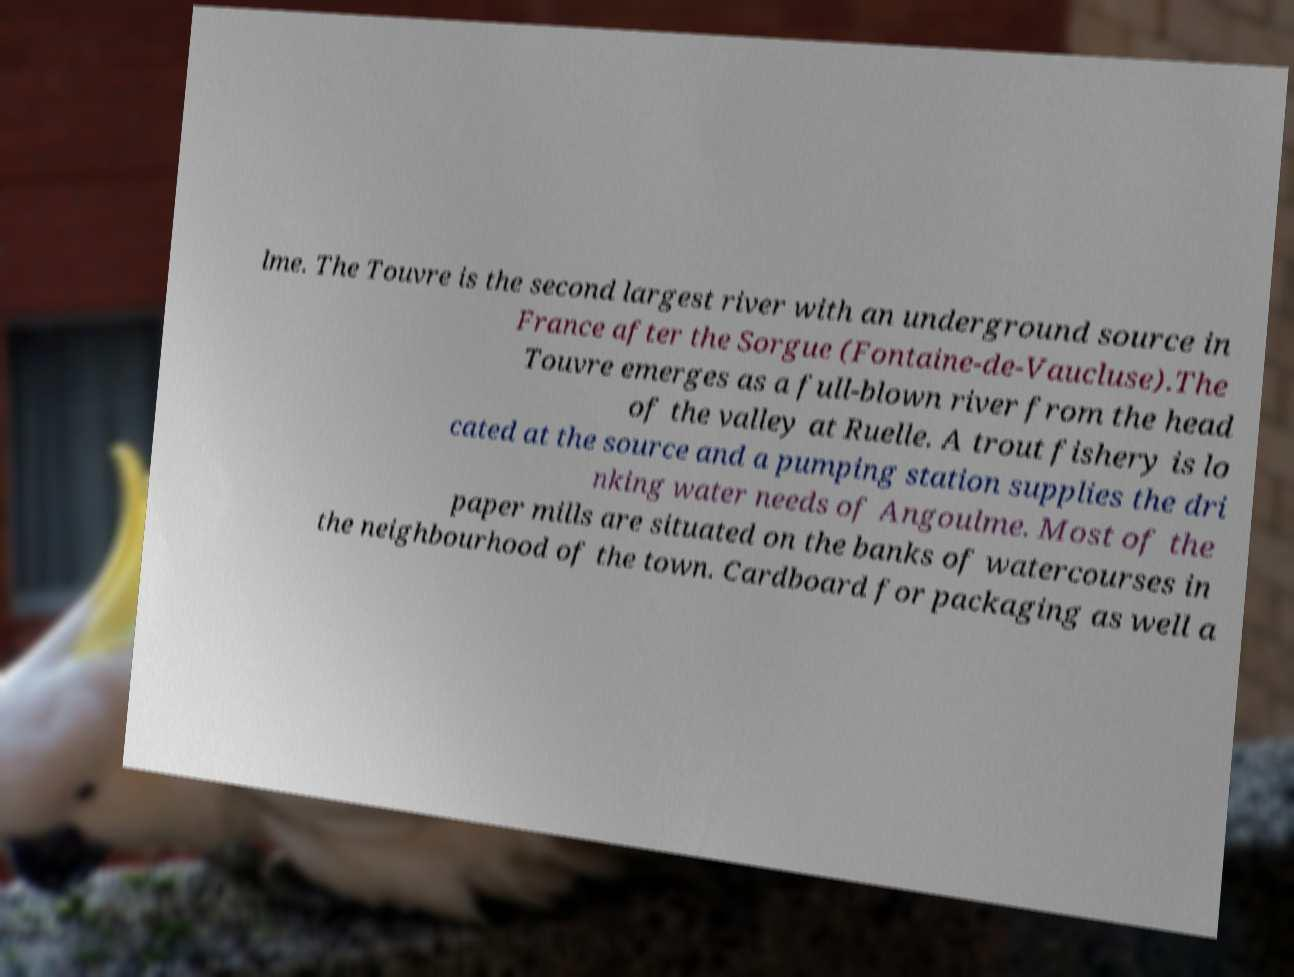Please read and relay the text visible in this image. What does it say? lme. The Touvre is the second largest river with an underground source in France after the Sorgue (Fontaine-de-Vaucluse).The Touvre emerges as a full-blown river from the head of the valley at Ruelle. A trout fishery is lo cated at the source and a pumping station supplies the dri nking water needs of Angoulme. Most of the paper mills are situated on the banks of watercourses in the neighbourhood of the town. Cardboard for packaging as well a 